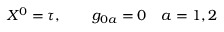<formula> <loc_0><loc_0><loc_500><loc_500>X ^ { 0 } = \tau , \quad g _ { 0 a } = 0 \quad a = 1 , 2</formula> 